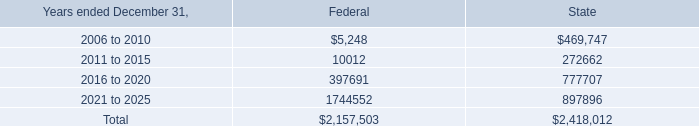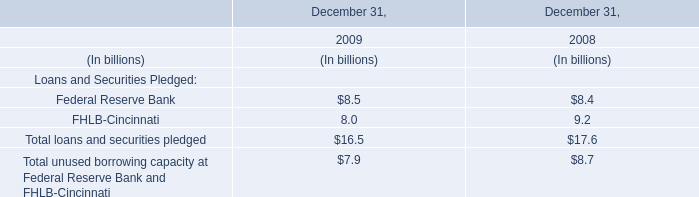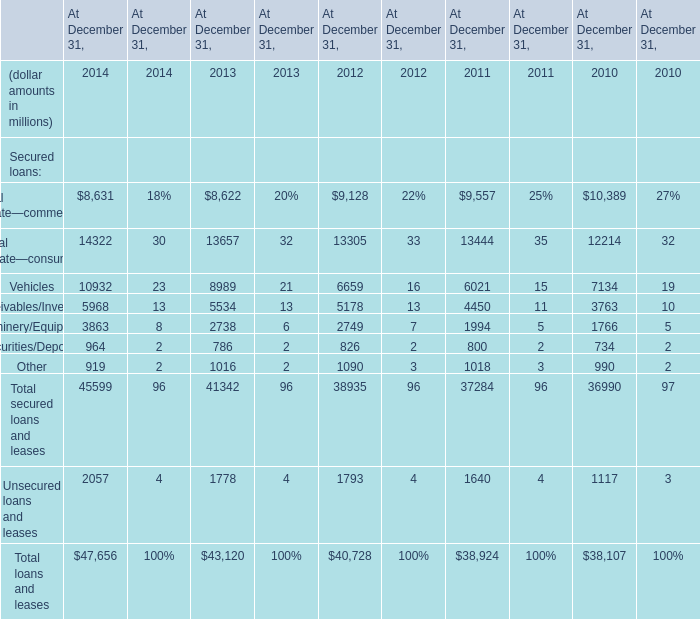what portion of total value of net operating loss carryforwards is related to state? 
Computations: (2418012 / (2157503 + 2418012))
Answer: 0.52847. 